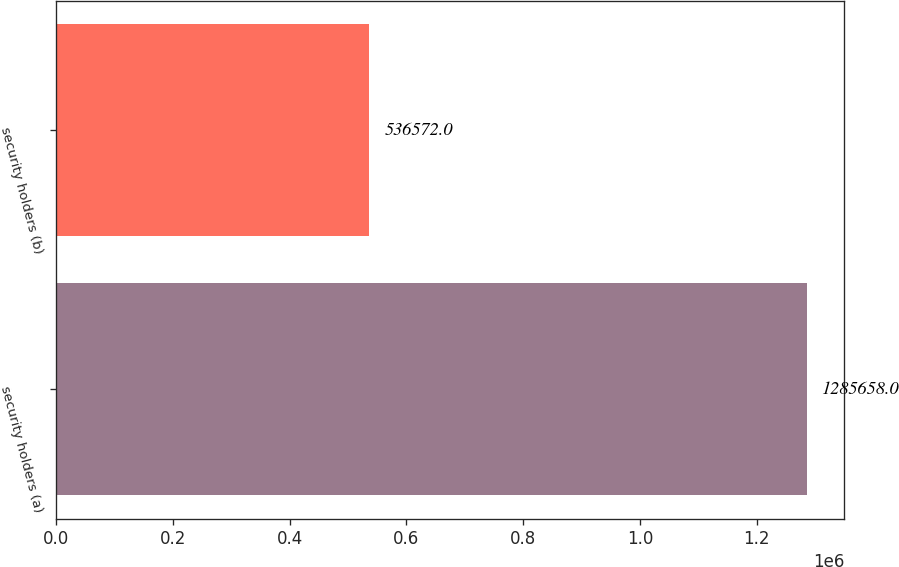<chart> <loc_0><loc_0><loc_500><loc_500><bar_chart><fcel>security holders (a)<fcel>security holders (b)<nl><fcel>1.28566e+06<fcel>536572<nl></chart> 